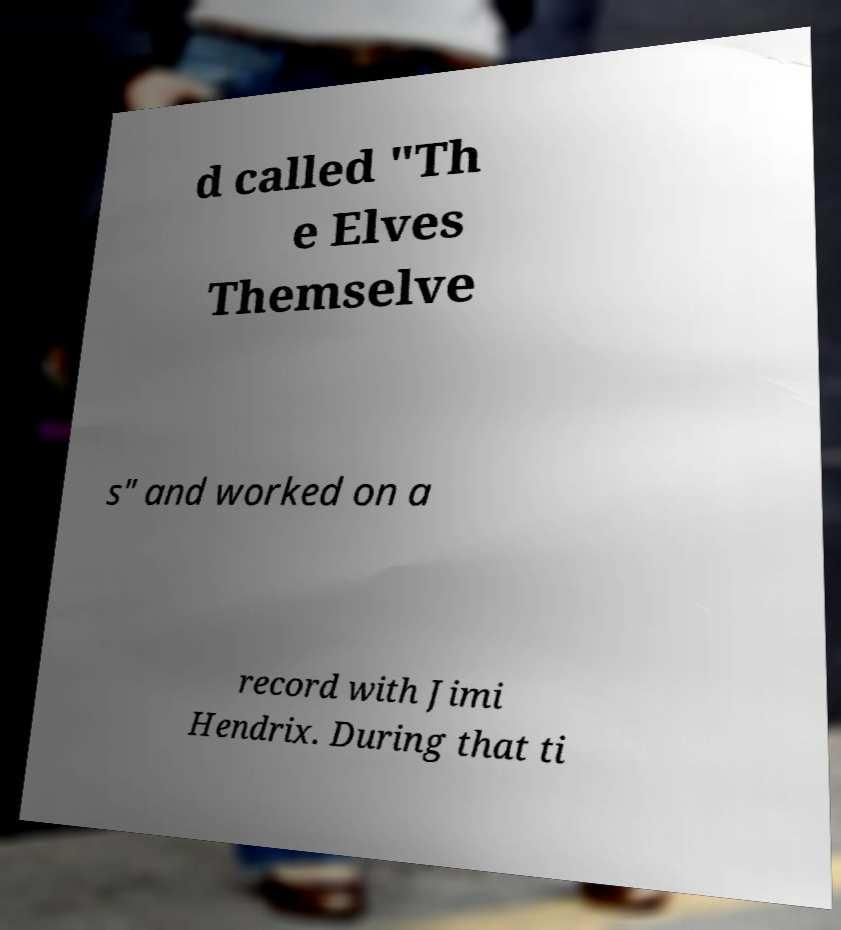Could you assist in decoding the text presented in this image and type it out clearly? d called "Th e Elves Themselve s" and worked on a record with Jimi Hendrix. During that ti 